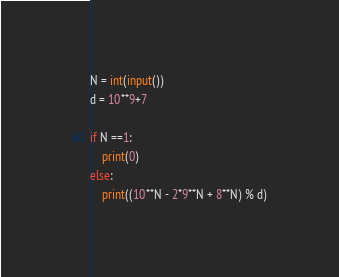Convert code to text. <code><loc_0><loc_0><loc_500><loc_500><_Python_>N = int(input())
d = 10**9+7

if N ==1:
    print(0)
else:
    print((10**N - 2*9**N + 8**N) % d)</code> 